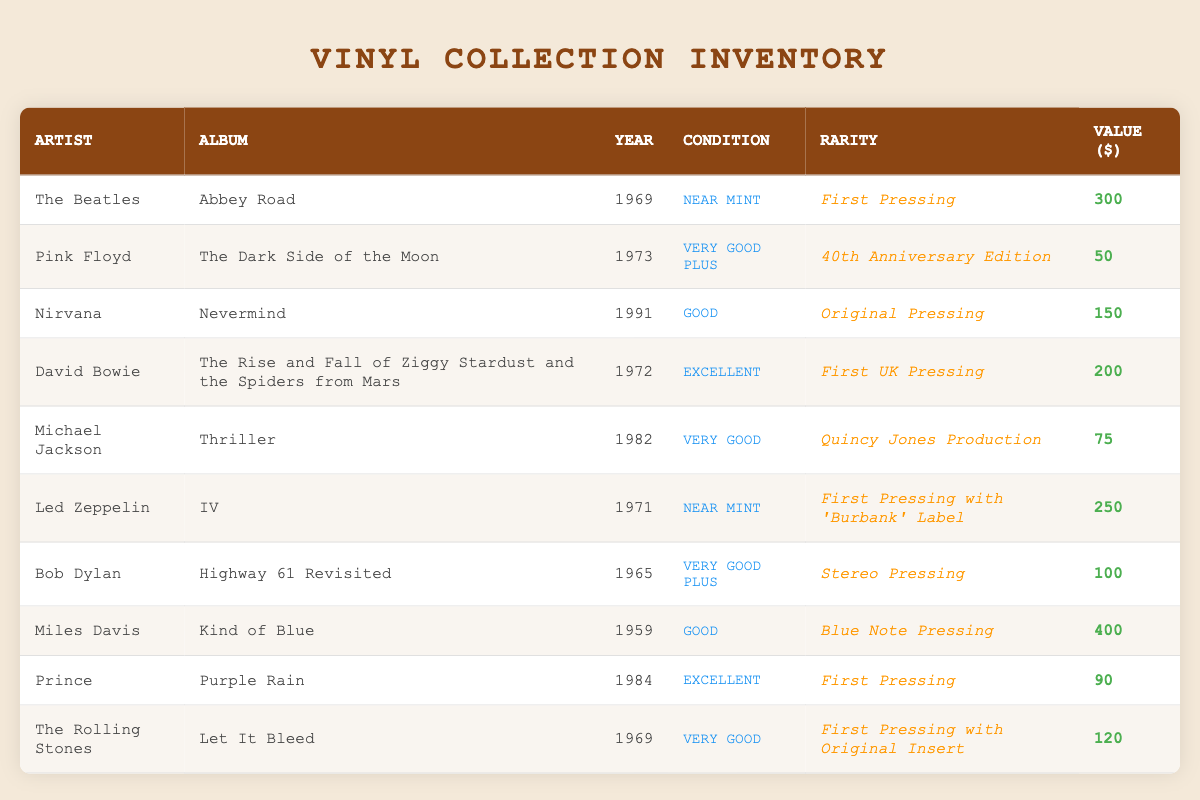What is the value of the album "Nevermind"? The table shows that "Nevermind" by Nirvana has a value listed in the fifth column, which is 150
Answer: 150 Which album has the highest value? By looking through all the values in the last column, "Kind of Blue" by Miles Davis has the highest value of 400
Answer: 400 How many albums were released before 1970? The albums released before 1970, as seen in the Year column, are "Highway 61 Revisited" (1965), "Abbey Road" (1969), and "Let It Bleed" (1969). That makes a total of 3 albums
Answer: 3 Is "The Dark Side of the Moon" a first pressing? The table states that "The Dark Side of the Moon" is the "40th Anniversary Edition", not a first pressing, which means the answer is no
Answer: No What is the average value of albums in "Excellent" condition? The albums in "Excellent" condition are "The Rise and Fall of Ziggy Stardust and the Spiders from Mars" with a value of 200 and "Purple Rain" valued at 90. Their sum is 290, and with 2 albums, the average is 290/2 = 145
Answer: 145 How many albums by Michael Jackson are listed in the inventory? There is only one entry listed under Michael Jackson, which is "Thriller". Therefore, the answer is one
Answer: 1 Which artist has the most valuable album from the 1960s? Examining the albums from the 1960s, "Abbey Road" by The Beatles (value 300) and "Highway 61 Revisited" by Bob Dylan (value 100) are the relevant entries. The highest value is for "Abbey Road", thus the answer is The Beatles
Answer: The Beatles What is the condition of the album "IV" by Led Zeppelin? In the table, the entry for "IV" by Led Zeppelin shows a condition listed as "Near Mint". Therefore, the answer is Near Mint
Answer: Near Mint Are there more albums that are in "Good" condition than in "Excellent" condition? The table lists two albums in "Good" condition ("Nevermind" and "Kind of Blue") and two in "Excellent" condition ("The Rise and Fall of Ziggy Stardust and the Spiders from Mars" and "Purple Rain"). Since both counts are equal, the answer is no
Answer: No 